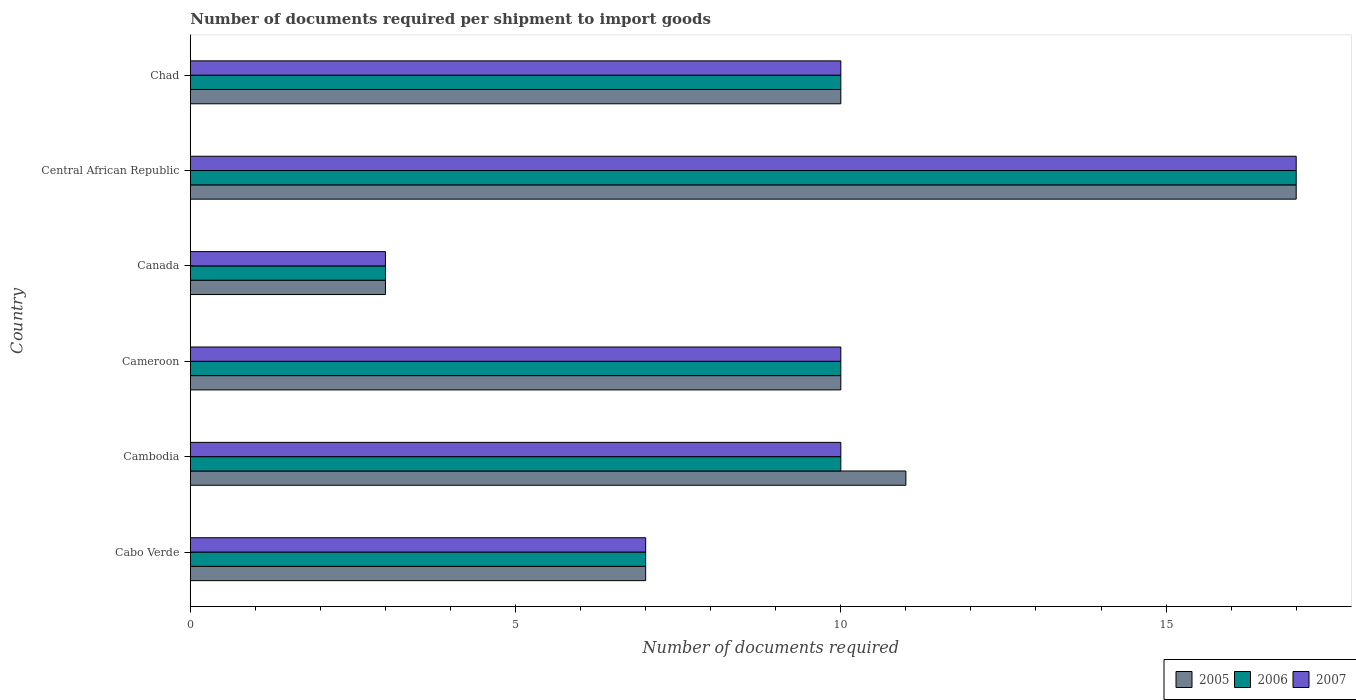How many bars are there on the 1st tick from the top?
Your answer should be very brief. 3. How many bars are there on the 6th tick from the bottom?
Offer a terse response. 3. What is the label of the 2nd group of bars from the top?
Your answer should be very brief. Central African Republic. In how many cases, is the number of bars for a given country not equal to the number of legend labels?
Provide a succinct answer. 0. Across all countries, what is the minimum number of documents required per shipment to import goods in 2005?
Your response must be concise. 3. In which country was the number of documents required per shipment to import goods in 2006 maximum?
Your response must be concise. Central African Republic. In which country was the number of documents required per shipment to import goods in 2005 minimum?
Make the answer very short. Canada. What is the total number of documents required per shipment to import goods in 2005 in the graph?
Provide a short and direct response. 58. What is the difference between the number of documents required per shipment to import goods in 2005 in Cambodia and that in Chad?
Provide a short and direct response. 1. What is the difference between the number of documents required per shipment to import goods in 2005 in Canada and the number of documents required per shipment to import goods in 2006 in Cabo Verde?
Make the answer very short. -4. What is the average number of documents required per shipment to import goods in 2005 per country?
Offer a very short reply. 9.67. What is the difference between the number of documents required per shipment to import goods in 2007 and number of documents required per shipment to import goods in 2006 in Cameroon?
Make the answer very short. 0. What is the ratio of the number of documents required per shipment to import goods in 2007 in Cabo Verde to that in Canada?
Ensure brevity in your answer.  2.33. Is the number of documents required per shipment to import goods in 2005 in Canada less than that in Central African Republic?
Ensure brevity in your answer.  Yes. Is the sum of the number of documents required per shipment to import goods in 2005 in Cabo Verde and Central African Republic greater than the maximum number of documents required per shipment to import goods in 2006 across all countries?
Provide a succinct answer. Yes. What does the 1st bar from the top in Cameroon represents?
Give a very brief answer. 2007. What does the 3rd bar from the bottom in Central African Republic represents?
Provide a short and direct response. 2007. How many bars are there?
Provide a short and direct response. 18. Are all the bars in the graph horizontal?
Provide a short and direct response. Yes. What is the difference between two consecutive major ticks on the X-axis?
Give a very brief answer. 5. How many legend labels are there?
Provide a succinct answer. 3. How are the legend labels stacked?
Offer a terse response. Horizontal. What is the title of the graph?
Make the answer very short. Number of documents required per shipment to import goods. Does "1990" appear as one of the legend labels in the graph?
Your response must be concise. No. What is the label or title of the X-axis?
Offer a very short reply. Number of documents required. What is the Number of documents required in 2005 in Cabo Verde?
Offer a terse response. 7. What is the Number of documents required in 2005 in Cameroon?
Your response must be concise. 10. What is the Number of documents required of 2006 in Canada?
Keep it short and to the point. 3. What is the Number of documents required of 2005 in Central African Republic?
Keep it short and to the point. 17. What is the Number of documents required in 2006 in Central African Republic?
Your response must be concise. 17. What is the Number of documents required in 2006 in Chad?
Offer a terse response. 10. What is the Number of documents required of 2007 in Chad?
Provide a succinct answer. 10. Across all countries, what is the maximum Number of documents required in 2006?
Make the answer very short. 17. Across all countries, what is the maximum Number of documents required in 2007?
Make the answer very short. 17. What is the total Number of documents required in 2006 in the graph?
Your answer should be compact. 57. What is the total Number of documents required in 2007 in the graph?
Your answer should be compact. 57. What is the difference between the Number of documents required of 2006 in Cabo Verde and that in Cameroon?
Your answer should be compact. -3. What is the difference between the Number of documents required of 2005 in Cabo Verde and that in Canada?
Offer a terse response. 4. What is the difference between the Number of documents required in 2007 in Cabo Verde and that in Canada?
Offer a terse response. 4. What is the difference between the Number of documents required in 2005 in Cabo Verde and that in Central African Republic?
Keep it short and to the point. -10. What is the difference between the Number of documents required in 2005 in Cabo Verde and that in Chad?
Provide a succinct answer. -3. What is the difference between the Number of documents required of 2006 in Cabo Verde and that in Chad?
Give a very brief answer. -3. What is the difference between the Number of documents required in 2005 in Cambodia and that in Cameroon?
Provide a short and direct response. 1. What is the difference between the Number of documents required of 2006 in Cambodia and that in Cameroon?
Your answer should be very brief. 0. What is the difference between the Number of documents required in 2005 in Cambodia and that in Canada?
Offer a terse response. 8. What is the difference between the Number of documents required in 2007 in Cambodia and that in Canada?
Offer a very short reply. 7. What is the difference between the Number of documents required in 2006 in Cambodia and that in Central African Republic?
Provide a short and direct response. -7. What is the difference between the Number of documents required in 2007 in Cambodia and that in Central African Republic?
Make the answer very short. -7. What is the difference between the Number of documents required in 2006 in Cambodia and that in Chad?
Give a very brief answer. 0. What is the difference between the Number of documents required of 2005 in Cameroon and that in Canada?
Ensure brevity in your answer.  7. What is the difference between the Number of documents required in 2006 in Cameroon and that in Canada?
Give a very brief answer. 7. What is the difference between the Number of documents required of 2006 in Cameroon and that in Central African Republic?
Offer a terse response. -7. What is the difference between the Number of documents required of 2007 in Cameroon and that in Central African Republic?
Your response must be concise. -7. What is the difference between the Number of documents required of 2006 in Cameroon and that in Chad?
Provide a short and direct response. 0. What is the difference between the Number of documents required of 2005 in Canada and that in Central African Republic?
Provide a succinct answer. -14. What is the difference between the Number of documents required in 2006 in Canada and that in Central African Republic?
Your answer should be very brief. -14. What is the difference between the Number of documents required in 2007 in Canada and that in Central African Republic?
Offer a very short reply. -14. What is the difference between the Number of documents required of 2005 in Canada and that in Chad?
Offer a very short reply. -7. What is the difference between the Number of documents required of 2007 in Canada and that in Chad?
Offer a terse response. -7. What is the difference between the Number of documents required in 2005 in Central African Republic and that in Chad?
Your answer should be very brief. 7. What is the difference between the Number of documents required of 2006 in Central African Republic and that in Chad?
Make the answer very short. 7. What is the difference between the Number of documents required in 2006 in Cabo Verde and the Number of documents required in 2007 in Cambodia?
Make the answer very short. -3. What is the difference between the Number of documents required in 2005 in Cabo Verde and the Number of documents required in 2006 in Cameroon?
Make the answer very short. -3. What is the difference between the Number of documents required in 2005 in Cabo Verde and the Number of documents required in 2007 in Cameroon?
Provide a short and direct response. -3. What is the difference between the Number of documents required in 2006 in Cabo Verde and the Number of documents required in 2007 in Cameroon?
Ensure brevity in your answer.  -3. What is the difference between the Number of documents required in 2005 in Cabo Verde and the Number of documents required in 2007 in Canada?
Your response must be concise. 4. What is the difference between the Number of documents required of 2005 in Cabo Verde and the Number of documents required of 2006 in Central African Republic?
Keep it short and to the point. -10. What is the difference between the Number of documents required of 2005 in Cabo Verde and the Number of documents required of 2007 in Chad?
Give a very brief answer. -3. What is the difference between the Number of documents required in 2005 in Cambodia and the Number of documents required in 2006 in Canada?
Keep it short and to the point. 8. What is the difference between the Number of documents required of 2005 in Cambodia and the Number of documents required of 2006 in Central African Republic?
Ensure brevity in your answer.  -6. What is the difference between the Number of documents required in 2005 in Cambodia and the Number of documents required in 2007 in Central African Republic?
Make the answer very short. -6. What is the difference between the Number of documents required of 2005 in Cambodia and the Number of documents required of 2006 in Chad?
Your answer should be compact. 1. What is the difference between the Number of documents required in 2005 in Cambodia and the Number of documents required in 2007 in Chad?
Make the answer very short. 1. What is the difference between the Number of documents required in 2005 in Cameroon and the Number of documents required in 2007 in Canada?
Your answer should be very brief. 7. What is the difference between the Number of documents required in 2005 in Cameroon and the Number of documents required in 2006 in Central African Republic?
Offer a terse response. -7. What is the difference between the Number of documents required in 2005 in Cameroon and the Number of documents required in 2007 in Central African Republic?
Offer a terse response. -7. What is the difference between the Number of documents required of 2005 in Cameroon and the Number of documents required of 2007 in Chad?
Your answer should be very brief. 0. What is the difference between the Number of documents required of 2005 in Canada and the Number of documents required of 2006 in Chad?
Your answer should be very brief. -7. What is the difference between the Number of documents required in 2005 in Canada and the Number of documents required in 2007 in Chad?
Provide a short and direct response. -7. What is the difference between the Number of documents required of 2006 in Canada and the Number of documents required of 2007 in Chad?
Offer a terse response. -7. What is the difference between the Number of documents required of 2006 in Central African Republic and the Number of documents required of 2007 in Chad?
Make the answer very short. 7. What is the average Number of documents required in 2005 per country?
Provide a short and direct response. 9.67. What is the average Number of documents required in 2006 per country?
Offer a very short reply. 9.5. What is the average Number of documents required of 2007 per country?
Make the answer very short. 9.5. What is the difference between the Number of documents required of 2005 and Number of documents required of 2006 in Cabo Verde?
Your response must be concise. 0. What is the difference between the Number of documents required of 2005 and Number of documents required of 2007 in Cabo Verde?
Offer a terse response. 0. What is the difference between the Number of documents required in 2005 and Number of documents required in 2006 in Cambodia?
Provide a succinct answer. 1. What is the difference between the Number of documents required of 2005 and Number of documents required of 2007 in Cambodia?
Offer a very short reply. 1. What is the difference between the Number of documents required in 2005 and Number of documents required in 2006 in Cameroon?
Offer a very short reply. 0. What is the difference between the Number of documents required of 2005 and Number of documents required of 2007 in Cameroon?
Your answer should be compact. 0. What is the difference between the Number of documents required of 2006 and Number of documents required of 2007 in Cameroon?
Offer a very short reply. 0. What is the difference between the Number of documents required of 2005 and Number of documents required of 2006 in Canada?
Your answer should be very brief. 0. What is the difference between the Number of documents required of 2005 and Number of documents required of 2006 in Chad?
Offer a terse response. 0. What is the ratio of the Number of documents required of 2005 in Cabo Verde to that in Cambodia?
Your response must be concise. 0.64. What is the ratio of the Number of documents required in 2006 in Cabo Verde to that in Cambodia?
Offer a very short reply. 0.7. What is the ratio of the Number of documents required of 2005 in Cabo Verde to that in Cameroon?
Offer a terse response. 0.7. What is the ratio of the Number of documents required in 2005 in Cabo Verde to that in Canada?
Keep it short and to the point. 2.33. What is the ratio of the Number of documents required in 2006 in Cabo Verde to that in Canada?
Make the answer very short. 2.33. What is the ratio of the Number of documents required in 2007 in Cabo Verde to that in Canada?
Make the answer very short. 2.33. What is the ratio of the Number of documents required of 2005 in Cabo Verde to that in Central African Republic?
Offer a terse response. 0.41. What is the ratio of the Number of documents required of 2006 in Cabo Verde to that in Central African Republic?
Your answer should be very brief. 0.41. What is the ratio of the Number of documents required in 2007 in Cabo Verde to that in Central African Republic?
Provide a succinct answer. 0.41. What is the ratio of the Number of documents required in 2005 in Cambodia to that in Cameroon?
Offer a terse response. 1.1. What is the ratio of the Number of documents required in 2006 in Cambodia to that in Cameroon?
Ensure brevity in your answer.  1. What is the ratio of the Number of documents required of 2005 in Cambodia to that in Canada?
Provide a succinct answer. 3.67. What is the ratio of the Number of documents required of 2007 in Cambodia to that in Canada?
Offer a very short reply. 3.33. What is the ratio of the Number of documents required of 2005 in Cambodia to that in Central African Republic?
Give a very brief answer. 0.65. What is the ratio of the Number of documents required in 2006 in Cambodia to that in Central African Republic?
Offer a very short reply. 0.59. What is the ratio of the Number of documents required of 2007 in Cambodia to that in Central African Republic?
Give a very brief answer. 0.59. What is the ratio of the Number of documents required of 2007 in Cameroon to that in Canada?
Ensure brevity in your answer.  3.33. What is the ratio of the Number of documents required of 2005 in Cameroon to that in Central African Republic?
Provide a short and direct response. 0.59. What is the ratio of the Number of documents required of 2006 in Cameroon to that in Central African Republic?
Your answer should be compact. 0.59. What is the ratio of the Number of documents required of 2007 in Cameroon to that in Central African Republic?
Your answer should be very brief. 0.59. What is the ratio of the Number of documents required of 2006 in Cameroon to that in Chad?
Keep it short and to the point. 1. What is the ratio of the Number of documents required in 2005 in Canada to that in Central African Republic?
Offer a very short reply. 0.18. What is the ratio of the Number of documents required of 2006 in Canada to that in Central African Republic?
Offer a very short reply. 0.18. What is the ratio of the Number of documents required of 2007 in Canada to that in Central African Republic?
Offer a terse response. 0.18. What is the ratio of the Number of documents required in 2005 in Canada to that in Chad?
Your answer should be very brief. 0.3. What is the ratio of the Number of documents required of 2006 in Canada to that in Chad?
Keep it short and to the point. 0.3. What is the ratio of the Number of documents required in 2006 in Central African Republic to that in Chad?
Your response must be concise. 1.7. What is the ratio of the Number of documents required of 2007 in Central African Republic to that in Chad?
Provide a succinct answer. 1.7. What is the difference between the highest and the second highest Number of documents required of 2006?
Provide a succinct answer. 7. What is the difference between the highest and the second highest Number of documents required of 2007?
Ensure brevity in your answer.  7. What is the difference between the highest and the lowest Number of documents required in 2006?
Your answer should be compact. 14. What is the difference between the highest and the lowest Number of documents required of 2007?
Give a very brief answer. 14. 